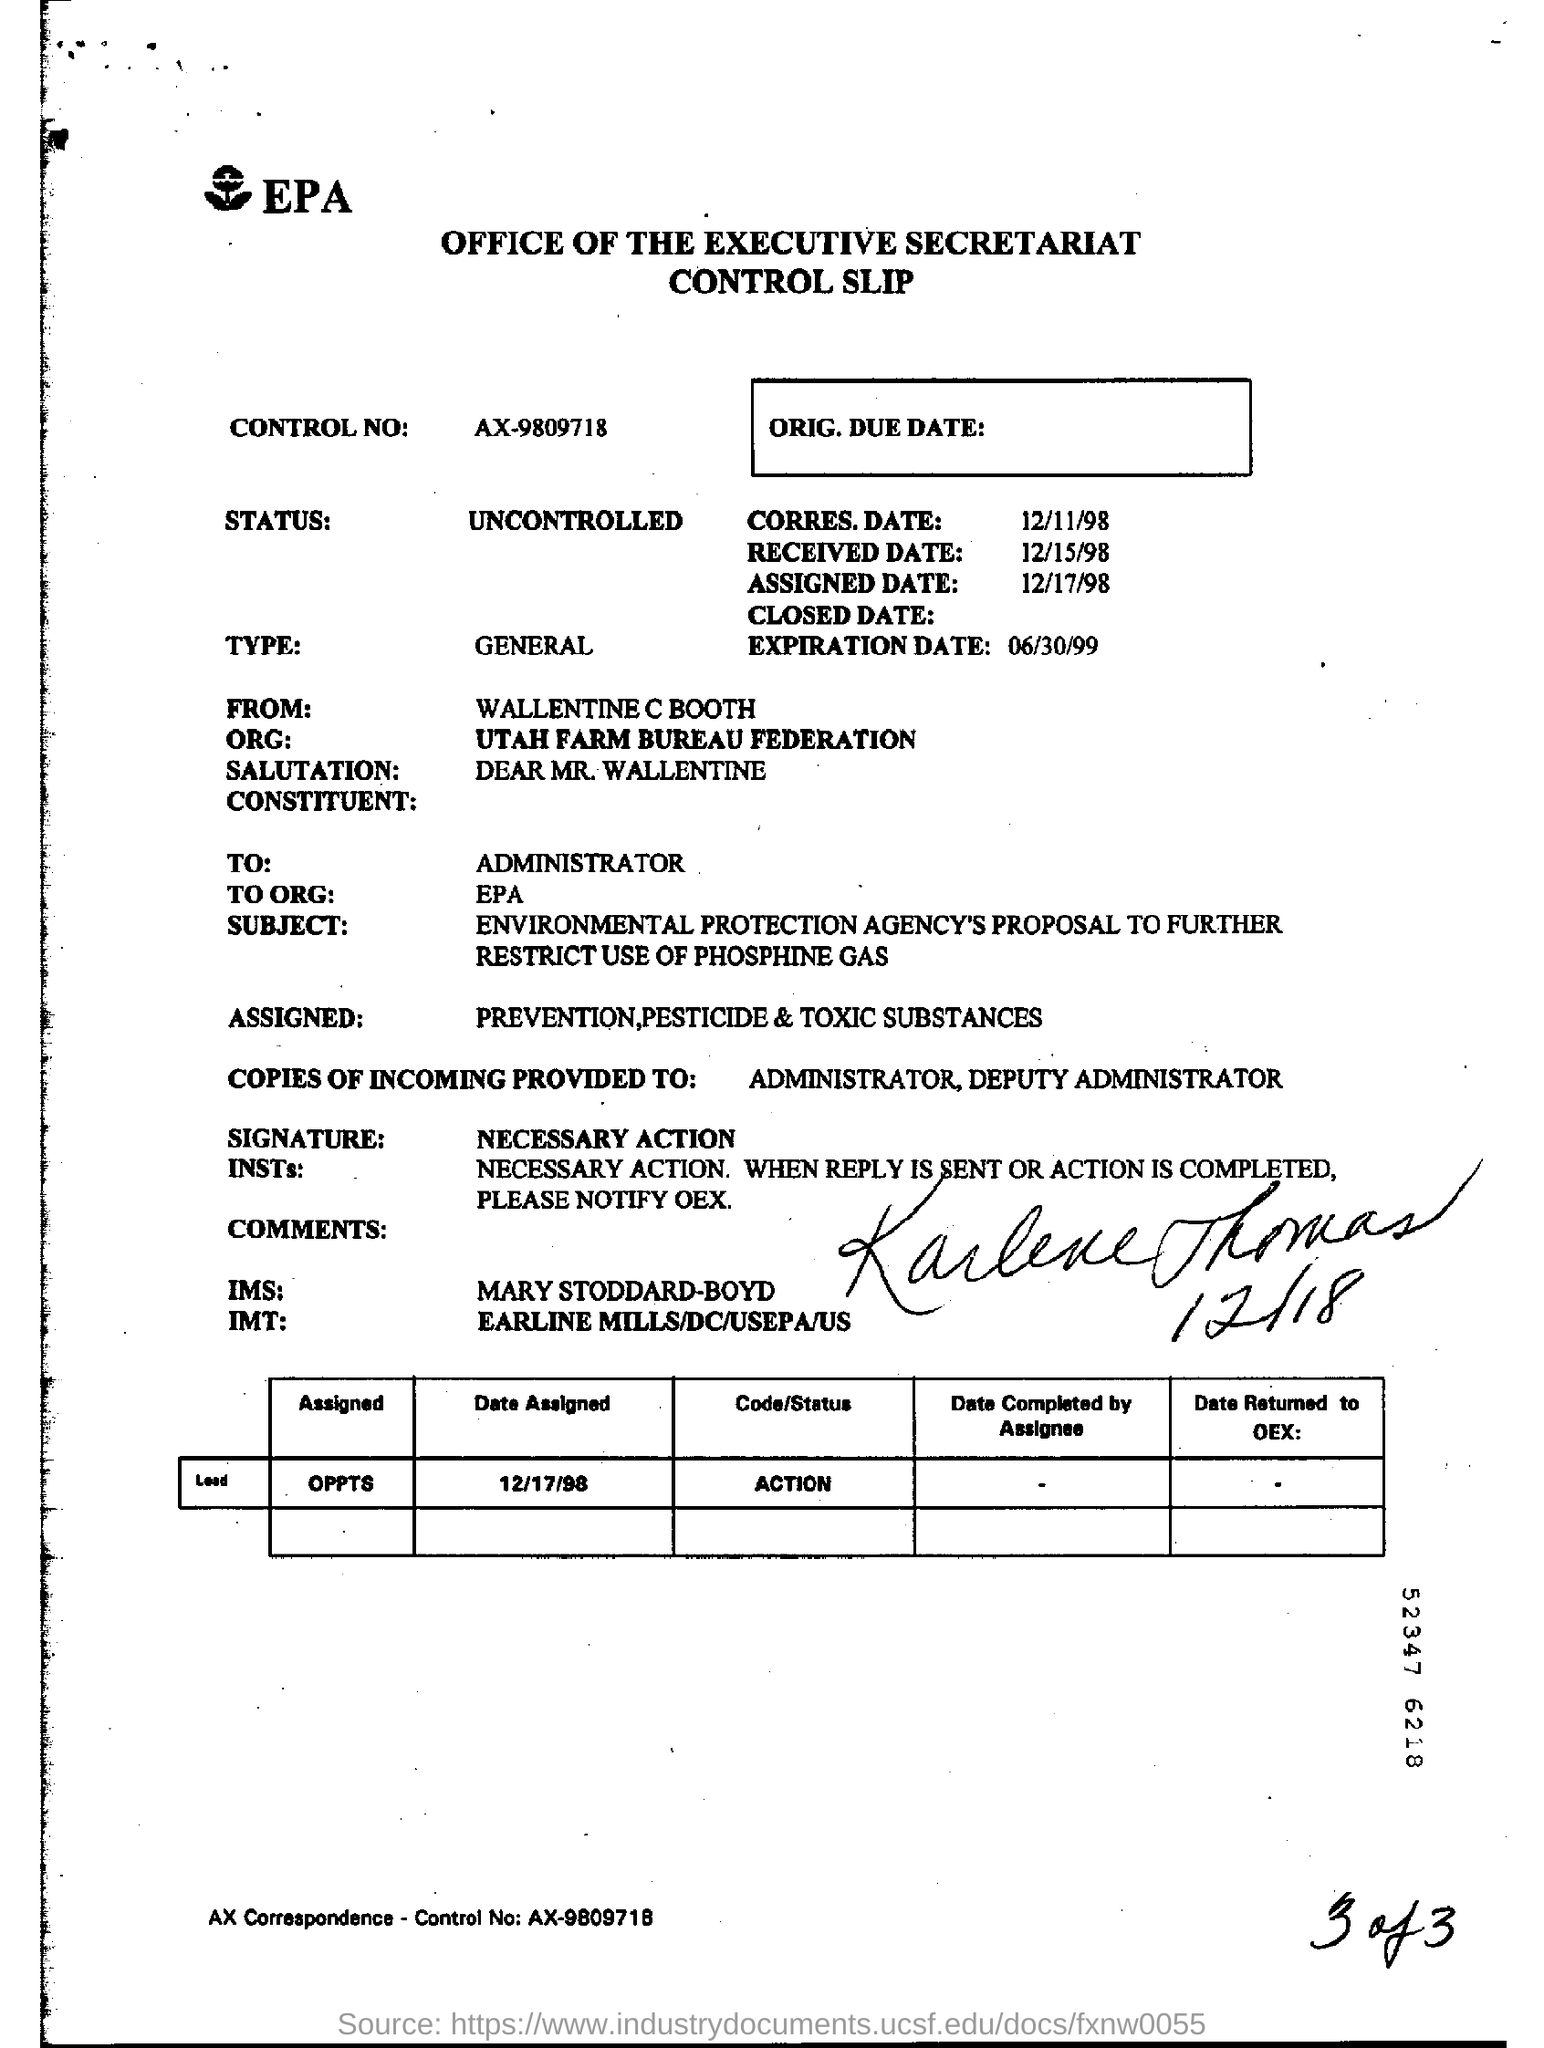What is the status? The document is marked as 'UNCONTROLLED,' which means it is not confidential and may be more widely accessible within or possibly outside the organization. This classification impacts how the document is handled, suggesting that it does not contain sensitive or restricted information, thus requiring less stringent controls. 